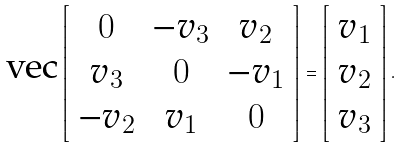Convert formula to latex. <formula><loc_0><loc_0><loc_500><loc_500>\text {vec} \left [ \begin{array} { c c c } 0 & - v _ { 3 } & v _ { 2 } \\ v _ { 3 } & 0 & - v _ { 1 } \\ - v _ { 2 } & v _ { 1 } & 0 \end{array} \right ] = \left [ \begin{array} { c } v _ { 1 } \\ v _ { 2 } \\ v _ { 3 } \end{array} \right ] .</formula> 